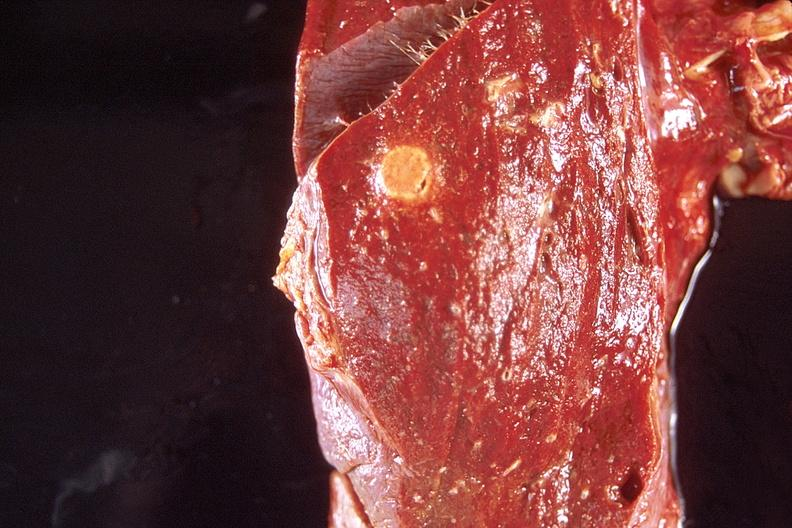where is this?
Answer the question using a single word or phrase. Lung 